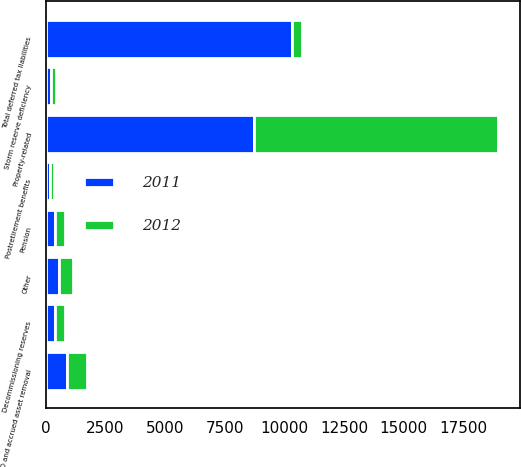Convert chart to OTSL. <chart><loc_0><loc_0><loc_500><loc_500><stacked_bar_chart><ecel><fcel>Property-related<fcel>Pension<fcel>Storm reserve deficiency<fcel>Other<fcel>Total deferred tax liabilities<fcel>Decommissioning reserves<fcel>Postretirement benefits<fcel>ARO and accrued asset removal<nl><fcel>2012<fcel>10206<fcel>403<fcel>212<fcel>563<fcel>418<fcel>418<fcel>162<fcel>832<nl><fcel>2011<fcel>8727<fcel>394<fcel>235<fcel>573<fcel>10295<fcel>406<fcel>170<fcel>884<nl></chart> 